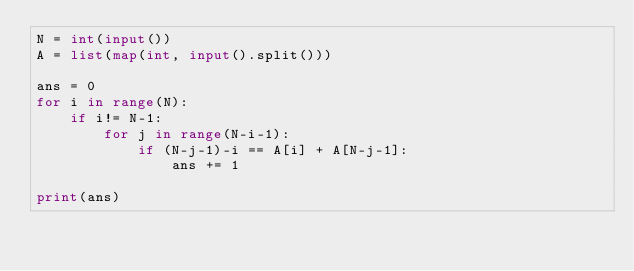<code> <loc_0><loc_0><loc_500><loc_500><_Python_>N = int(input())
A = list(map(int, input().split()))

ans = 0
for i in range(N):
    if i!= N-1:
        for j in range(N-i-1):
            if (N-j-1)-i == A[i] + A[N-j-1]:
                ans += 1

print(ans)                </code> 